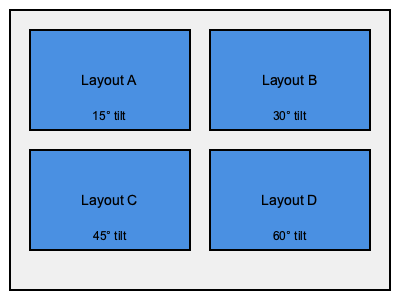Given the four solar panel layouts shown above, which one would likely provide the highest energy output for a rooftop installation at a latitude of 40°N? To determine the most efficient solar panel layout, we need to consider the relationship between panel tilt angle and latitude:

1. Optimal tilt angle: The general rule of thumb is that the optimal tilt angle for fixed solar panels is approximately equal to the latitude of the installation location.

2. Given latitude: The question specifies a latitude of 40°N.

3. Comparing tilt angles:
   Layout A: 15° tilt
   Layout B: 30° tilt
   Layout C: 45° tilt
   Layout D: 60° tilt

4. Efficiency consideration: Panels perform best when they receive direct sunlight perpendicular to their surface.

5. Matching latitude: The tilt angle closest to the given latitude of 40°N would likely provide the highest energy output.

6. Evaluation:
   Layout C with a 45° tilt is the closest match to the 40°N latitude.

7. Additional factors: While not explicitly mentioned, it's worth noting that factors such as local climate, shading, and seasonal variations can also impact overall efficiency.
Answer: Layout C (45° tilt) 